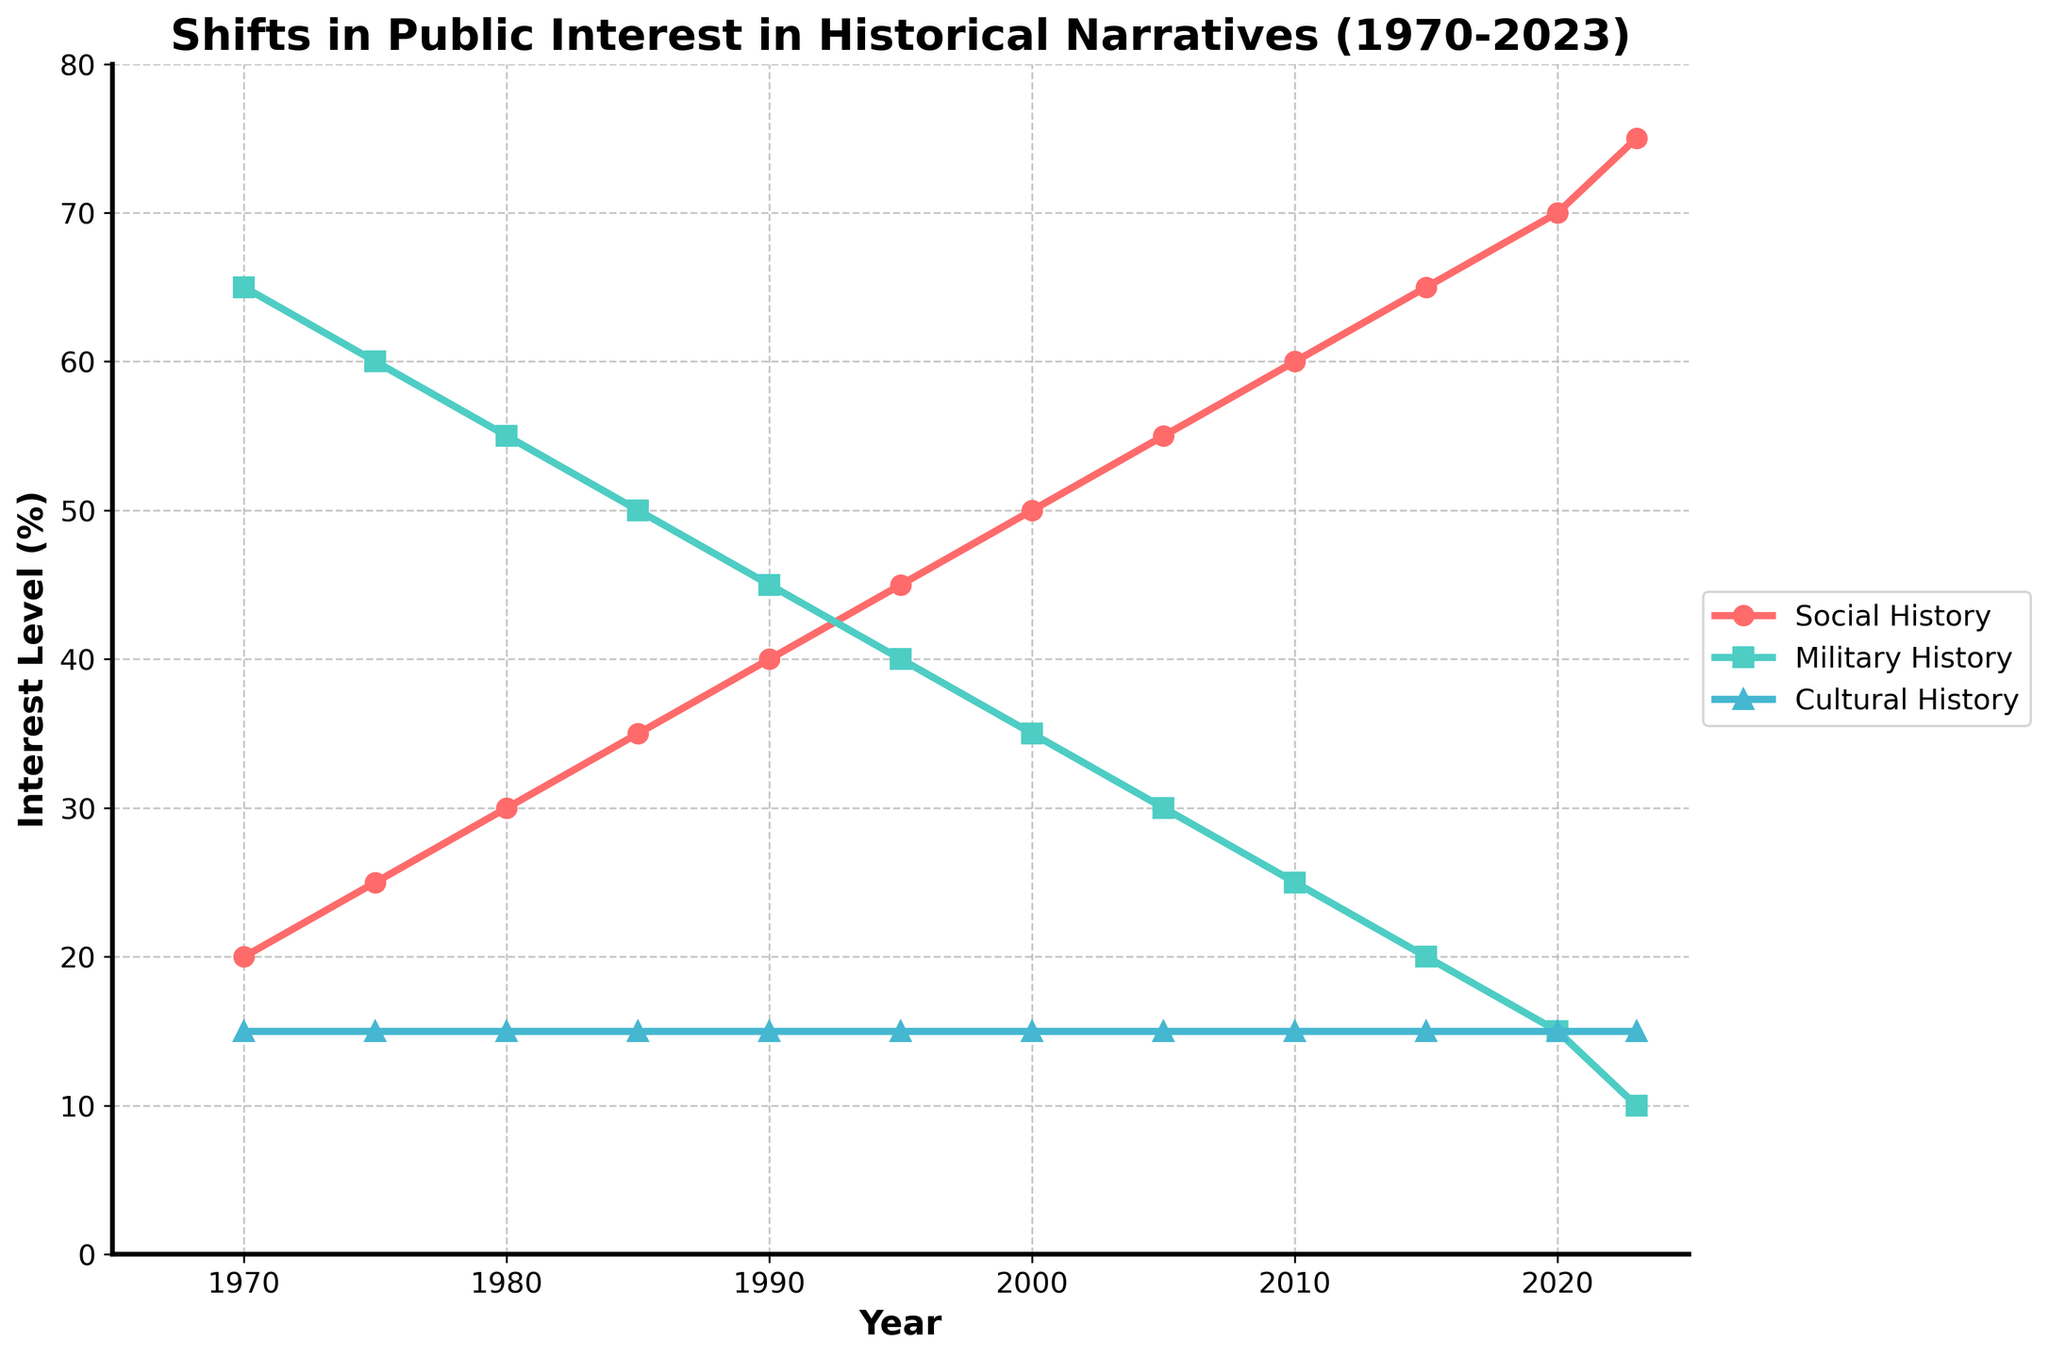What year did Social History surpass Military History in public interest? By looking at the plot, we find the point where the red line (Social History) crosses the green line (Military History). This occurs around 1995.
Answer: 1995 Which type of historical narrative shows no change in public interest from 1970 to 2023? The plot shows that the blue line (Cultural History) remains flat over time, indicating no change in public interest.
Answer: Cultural History What is the difference in public interest between Social History and Military History in 2023? The value of Social History in 2023 is 75%, and the value of Military History is 10%. The difference is 75% - 10% = 65%.
Answer: 65% Which historical narrative had the highest public interest in 1970? The highest point on the plot in 1970 is the green line (Military History) at 65%.
Answer: Military History Between which years did Social History see the most significant increase in public interest? By examining the slope of the red line (Social History), the most significant increase occurred between 2015 and 2020.
Answer: 2015-2020 What was the public interest in Military History in the year 2000? The green line (Military History) at the year 2000 shows a value of 35%.
Answer: 35% What is the median value of Social History public interest between 1970 and 2023? The values for Social History are: 20, 25, 30, 35, 40, 45, 50, 55, 60, 65, 70, 75. The median is the average of the 6th and 7th values, (45+50)/2 = 47.5.
Answer: 47.5 By how much did Cultural History public interest change from 1970 to 2023? The blue line (Cultural History) remains at 15% throughout the years, so the change is 0%.
Answer: 0% What is the average public interest in Social History from 1970 to 2023? The values for Social History are: 20, 25, 30, 35, 40, 45, 50, 55, 60, 65, 70, 75. Sum these values to get 570, then divide by 12 (the number of years): 570/12 = 47.5.
Answer: 47.5 